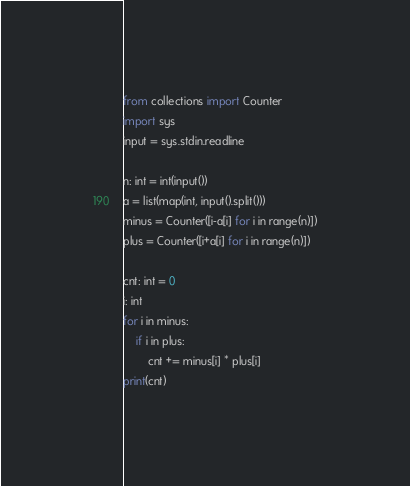<code> <loc_0><loc_0><loc_500><loc_500><_Cython_>from collections import Counter
import sys
input = sys.stdin.readline

n: int = int(input())
a = list(map(int, input().split()))
minus = Counter([i-a[i] for i in range(n)])
plus = Counter([i+a[i] for i in range(n)])

cnt: int = 0
i: int
for i in minus:
    if i in plus:
        cnt += minus[i] * plus[i]
print(cnt)
</code> 